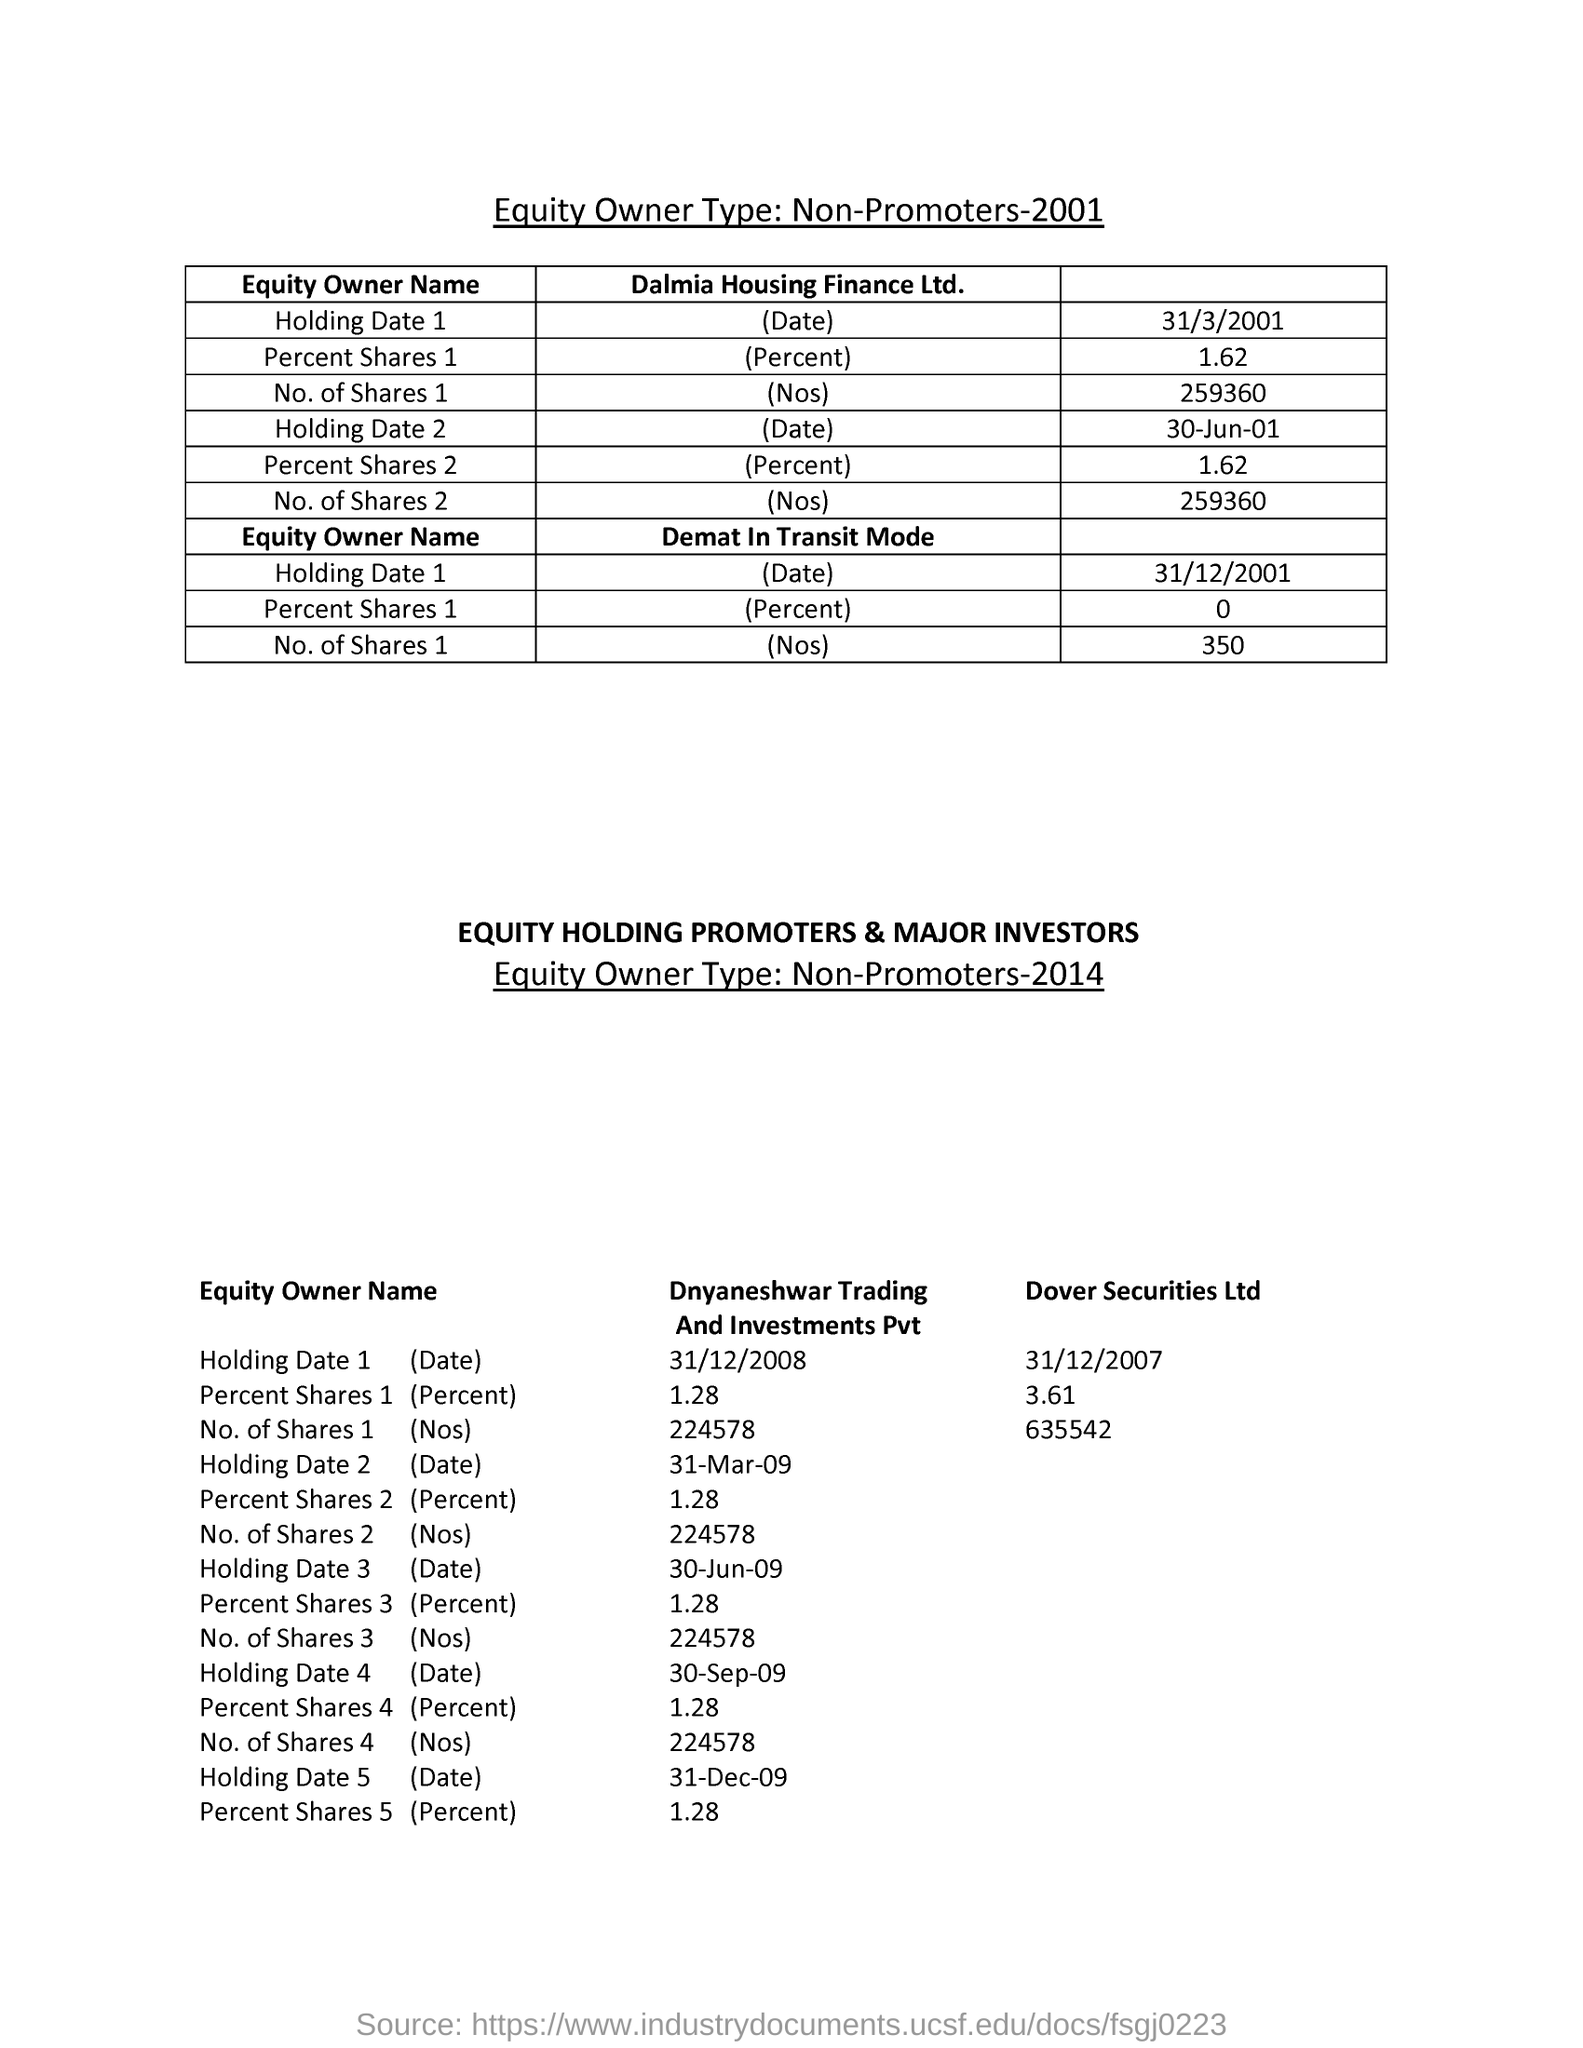Indicate a few pertinent items in this graphic. The "Holding Date 1" shown in the second row was March 31, 2001. 